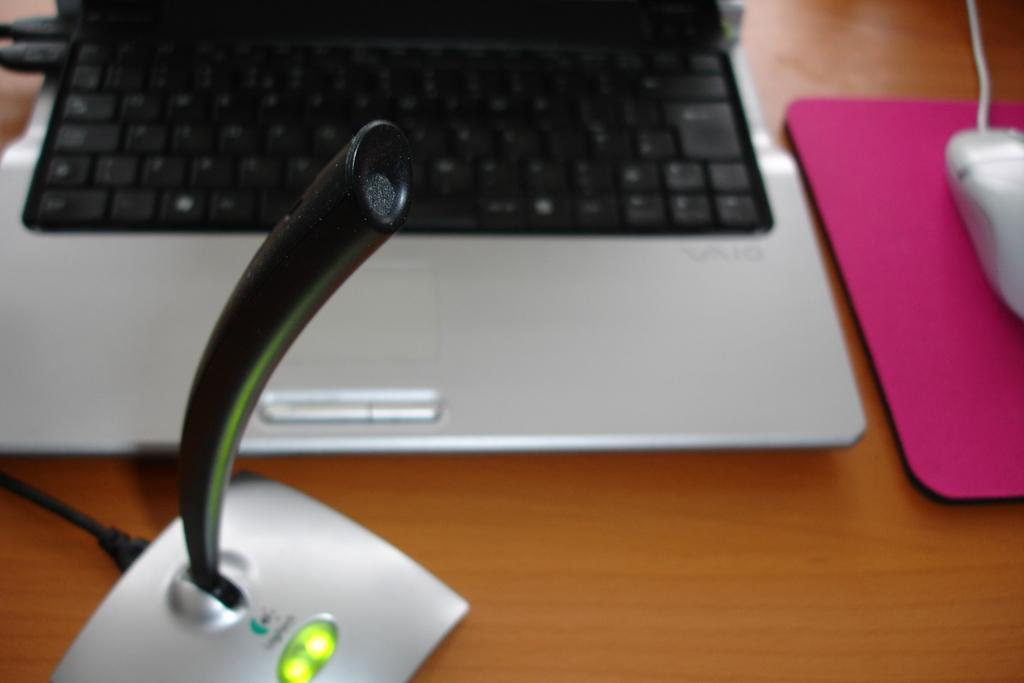What piece of furniture is present in the image? There is a table in the image. What electronic device is on the table? There is a laptop on the table. What accessory is also present on the table? There is a mouse on the table. What type of engine can be seen under the table in the image? There is no engine present under the table in the image. How many bananas are on the table in the image? There are no bananas present on the table in the image. 